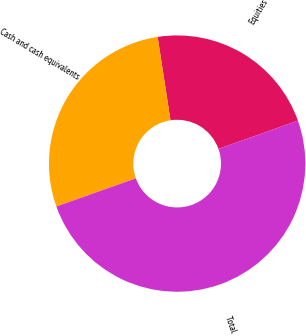Convert chart. <chart><loc_0><loc_0><loc_500><loc_500><pie_chart><fcel>Equities<fcel>Cash and cash equivalents<fcel>Total<nl><fcel>22.0%<fcel>28.0%<fcel>50.0%<nl></chart> 